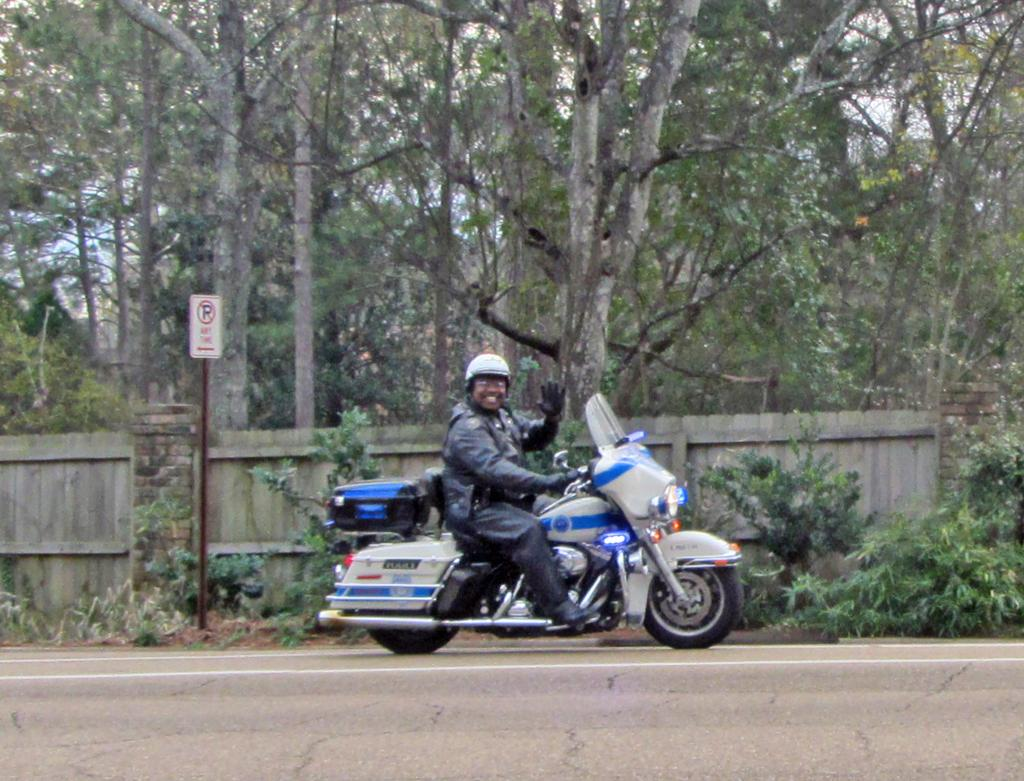What is the man in the image doing? The man is riding a motorbike in the image. What is the man's facial expression? The man is smiling in the image. Where is the motorbike located? The motorbike is in the street. What can be seen in the background of the image? In the background of the image, there are plants, a sign board, a pole, trees, a fence, and the sky. How many lizards are crawling on the man's mouth in the image? There are no lizards present in the image, and therefore none are crawling on the man's mouth. 